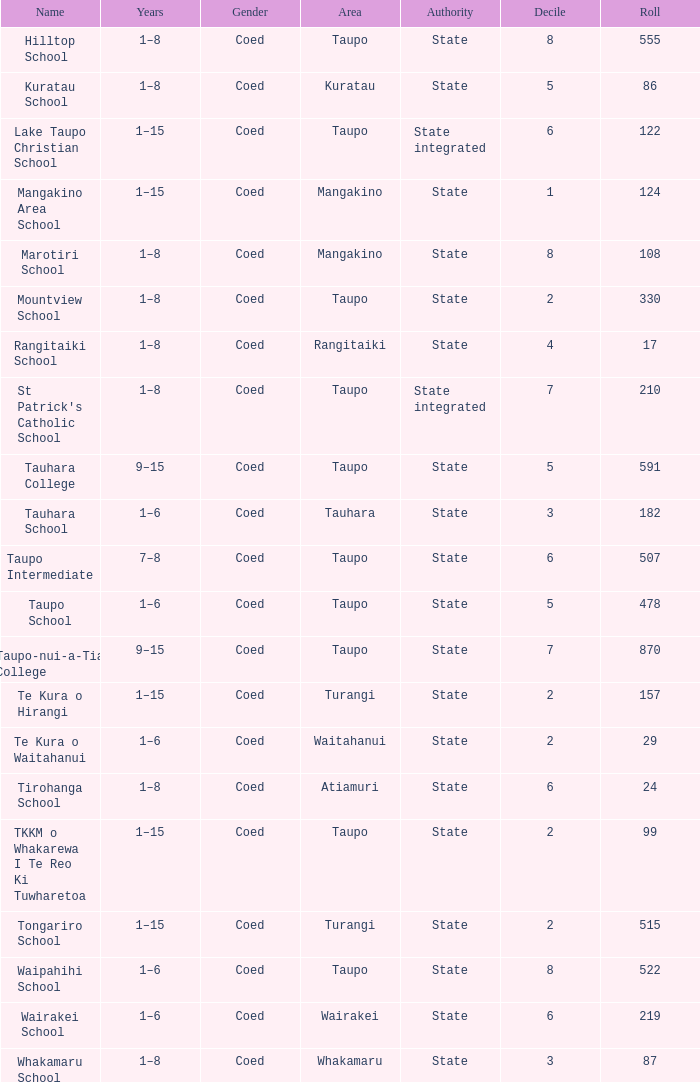Where can one find the state-run school that has an enrollment of over 157 students? Taupo, Taupo, Taupo, Tauhara, Taupo, Taupo, Taupo, Turangi, Taupo, Wairakei. 